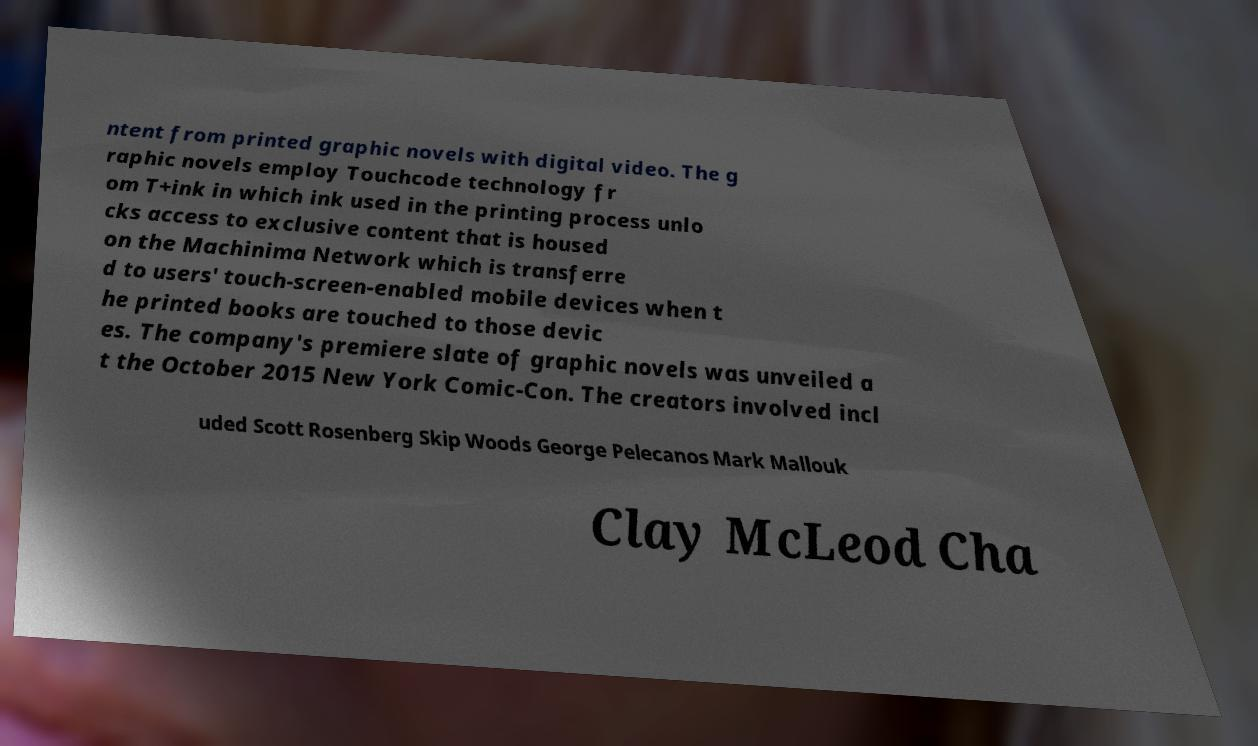Could you extract and type out the text from this image? ntent from printed graphic novels with digital video. The g raphic novels employ Touchcode technology fr om T+ink in which ink used in the printing process unlo cks access to exclusive content that is housed on the Machinima Network which is transferre d to users' touch-screen-enabled mobile devices when t he printed books are touched to those devic es. The company's premiere slate of graphic novels was unveiled a t the October 2015 New York Comic-Con. The creators involved incl uded Scott Rosenberg Skip Woods George Pelecanos Mark Mallouk Clay McLeod Cha 